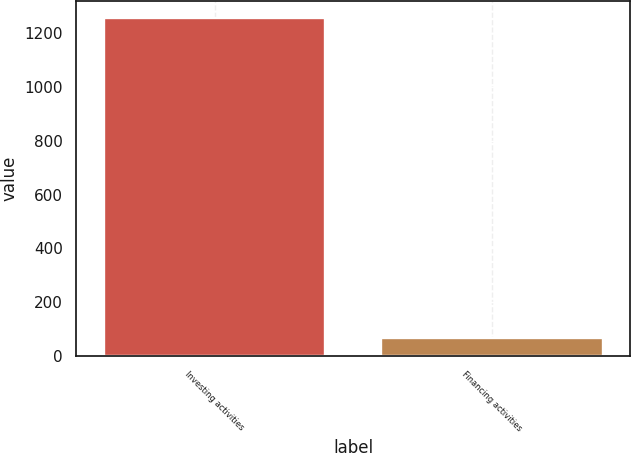Convert chart. <chart><loc_0><loc_0><loc_500><loc_500><bar_chart><fcel>Investing activities<fcel>Financing activities<nl><fcel>1255<fcel>66<nl></chart> 